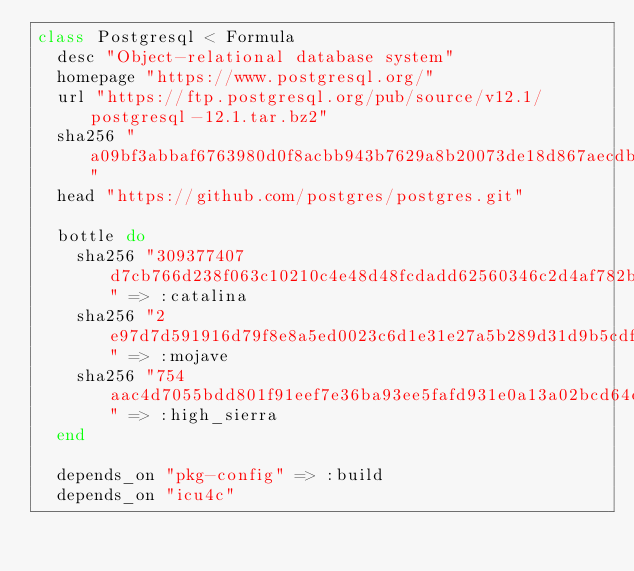Convert code to text. <code><loc_0><loc_0><loc_500><loc_500><_Ruby_>class Postgresql < Formula
  desc "Object-relational database system"
  homepage "https://www.postgresql.org/"
  url "https://ftp.postgresql.org/pub/source/v12.1/postgresql-12.1.tar.bz2"
  sha256 "a09bf3abbaf6763980d0f8acbb943b7629a8b20073de18d867aecdb7988483ed"
  head "https://github.com/postgres/postgres.git"

  bottle do
    sha256 "309377407d7cb766d238f063c10210c4e48d48fcdadd62560346c2d4af782bc4" => :catalina
    sha256 "2e97d7d591916d79f8e8a5ed0023c6d1e31e27a5b289d31d9b5cdf51e1d3a040" => :mojave
    sha256 "754aac4d7055bdd801f91eef7e36ba93ee5fafd931e0a13a02bcd64e71ff34a9" => :high_sierra
  end

  depends_on "pkg-config" => :build
  depends_on "icu4c"</code> 